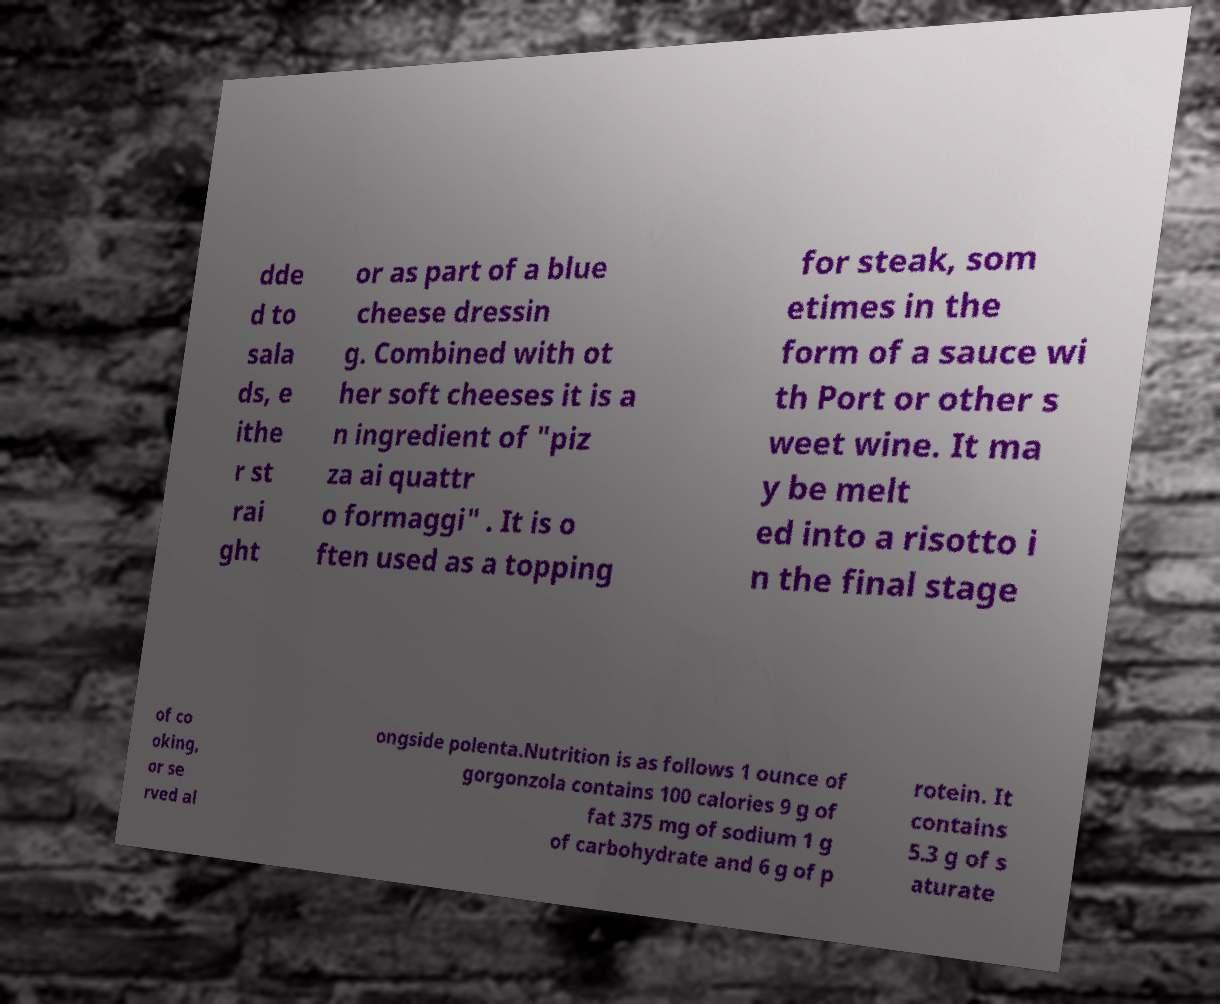What are some health considerations to keep in mind when consuming gorgonzola cheese as depicted in the image? Gorgonzola cheese, as noted in the image, contains significant amounts of fat and sodium — 9 grams of fat and 375 mg of sodium per ounce. Those monitoring their calorie intake or managing conditions like hypertension should consider these factors. It provides 6 grams of protein per serving, but also contains 5.3 grams of saturated fats, which should be consumed in moderation to maintain heart health. 